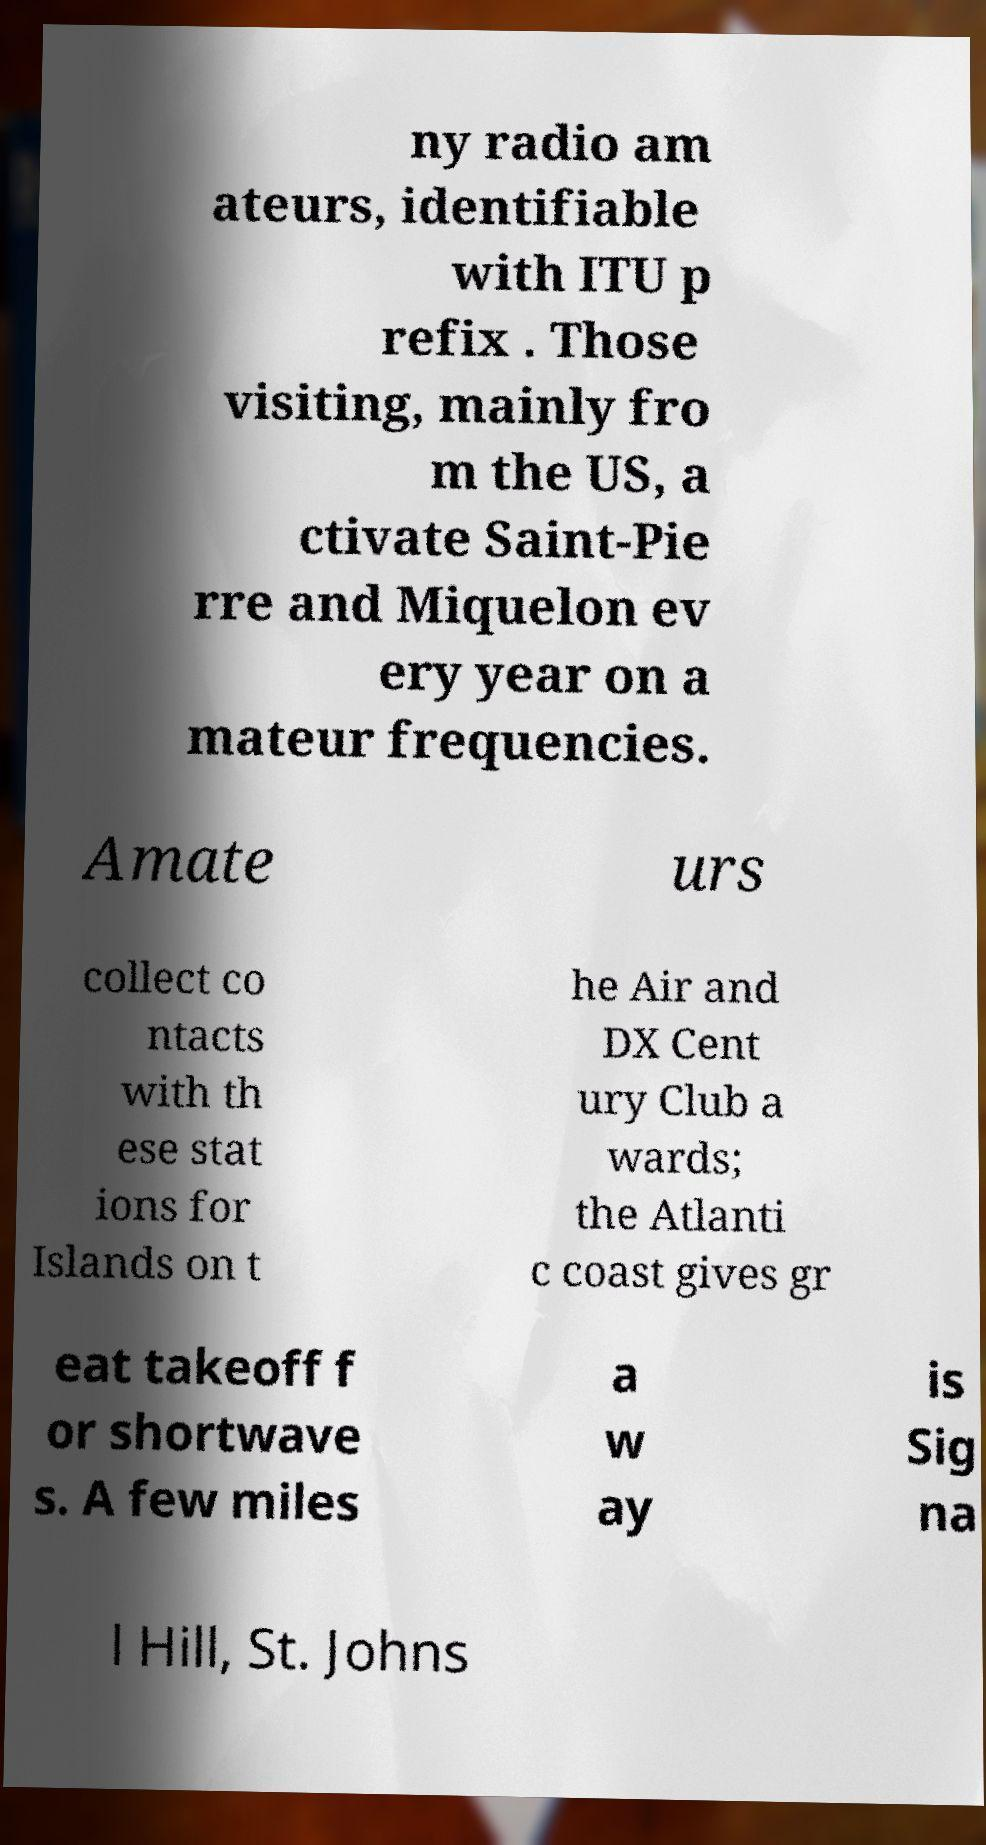I need the written content from this picture converted into text. Can you do that? ny radio am ateurs, identifiable with ITU p refix . Those visiting, mainly fro m the US, a ctivate Saint-Pie rre and Miquelon ev ery year on a mateur frequencies. Amate urs collect co ntacts with th ese stat ions for Islands on t he Air and DX Cent ury Club a wards; the Atlanti c coast gives gr eat takeoff f or shortwave s. A few miles a w ay is Sig na l Hill, St. Johns 